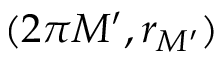Convert formula to latex. <formula><loc_0><loc_0><loc_500><loc_500>( 2 \pi M ^ { \prime } , r _ { M ^ { \prime } } )</formula> 